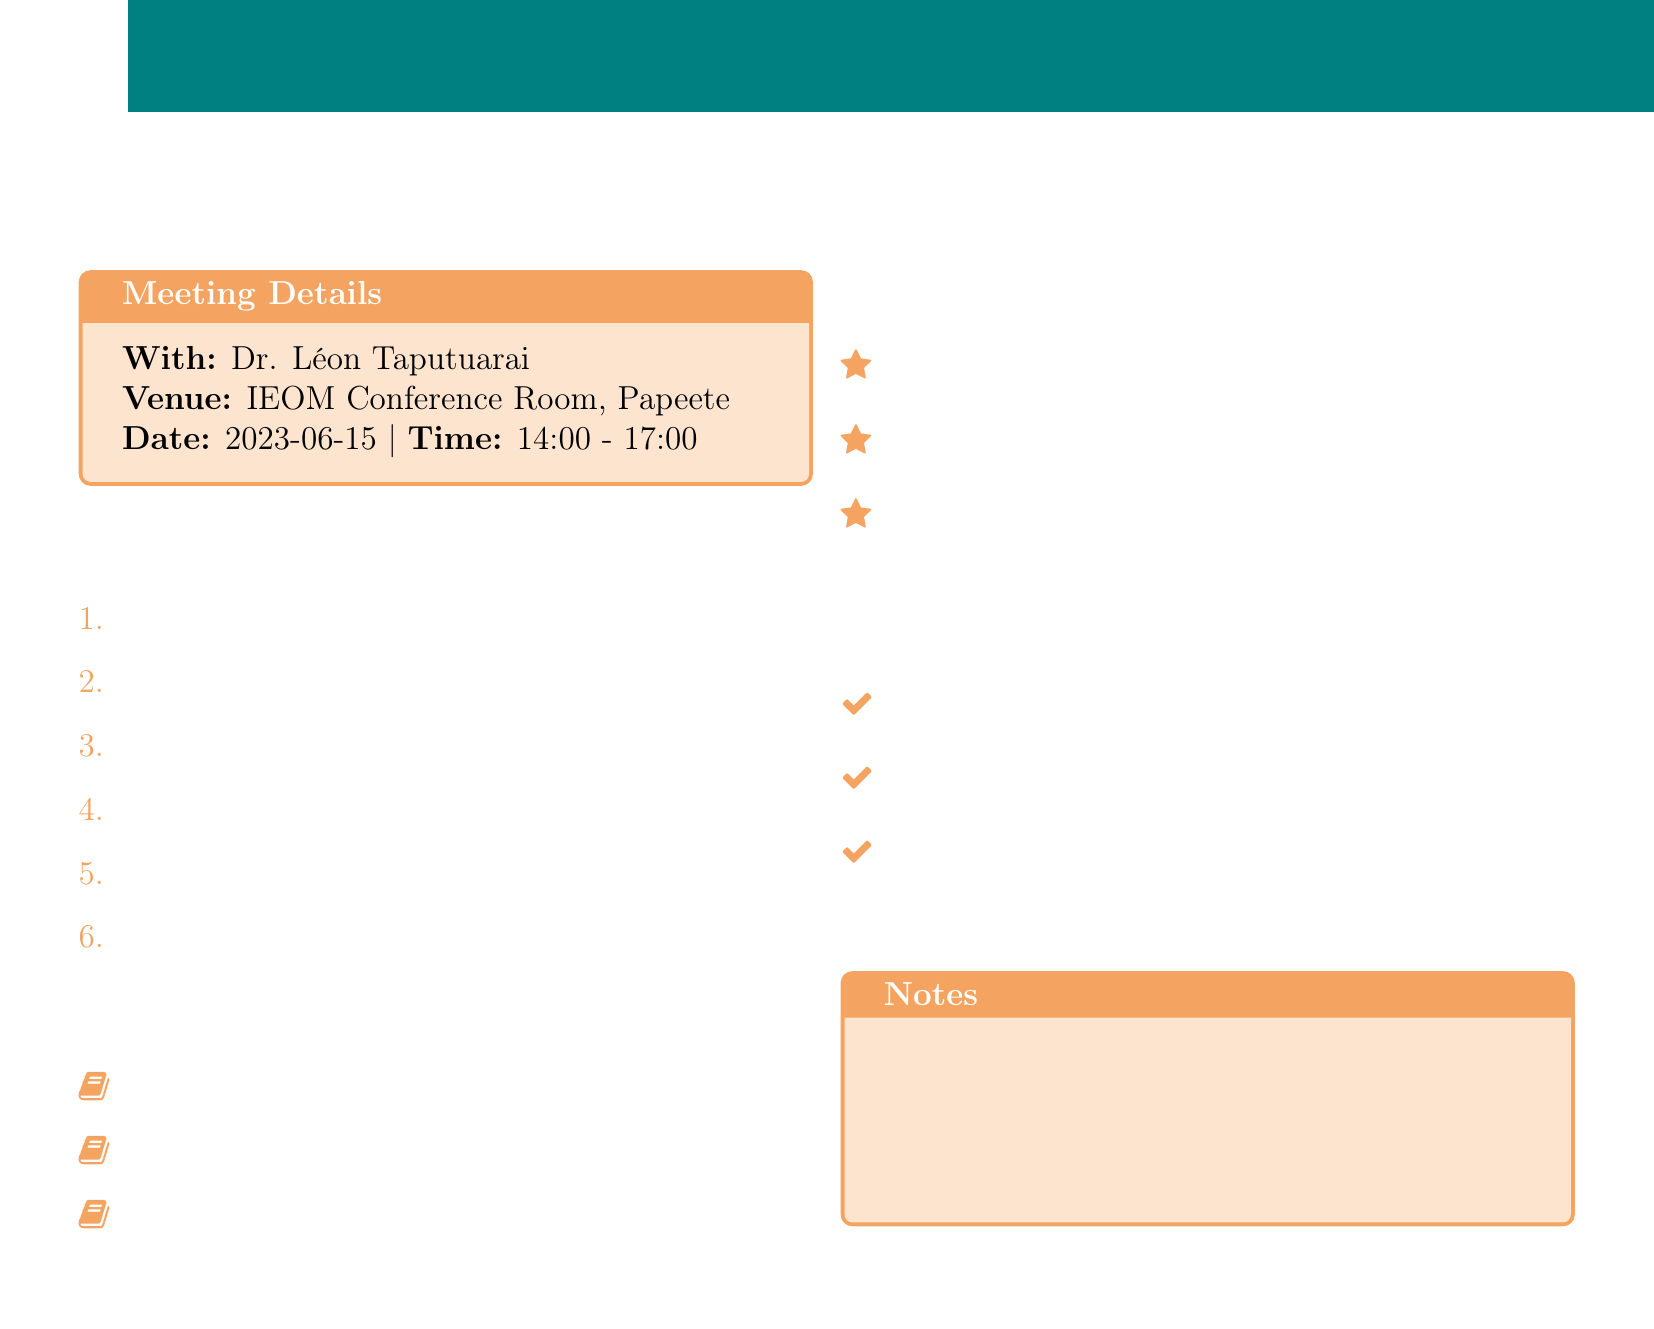What is the name of the historian? The document lists Dr. Léon Taputuarai as the historian with whom the meeting is scheduled.
Answer: Dr. Léon Taputuarai When was the meeting scheduled? The meeting date is provided in the document as June 15, 2023.
Answer: 2023-06-15 What is the venue for the meeting? The document specifies the meeting will take place at the Institut d'Émission d'Outre-Mer (IEOM) Conference Room in Papeete.
Answer: IEOM Conference Room, Papeete How many banks are mentioned in the document? The document states that there are three banks mentioned regarding the financial institutions in French Polynesia.
Answer: 3 What significant financial event occurred in 1967? The document indicates the creation of the Institut d'Émission d'Outre-Mer (IEOM) in 1967 as a key development.
Answer: Creation of Institut d'Émission d'Outre-Mer (IEOM) Who contributed to financial development in the region? The document highlights Paul-Émile Victor as a key figure in financial development in French Polynesia.
Answer: Paul-Émile Victor What is the total asset value mentioned for 2022? The document provides the total assets as 1.2 trillion CFP francs for the year 2022.
Answer: 1.2 trillion CFP francs What is a follow-up action listed in the document? The document includes several follow-up actions, including scheduling a visit to the Banque de Tahiti archives, as one of the actions.
Answer: Schedule visit to Banque de Tahiti archives 